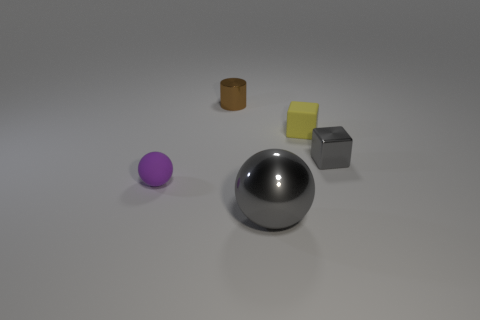Add 5 tiny metallic blocks. How many objects exist? 10 Subtract all balls. How many objects are left? 3 Add 1 small purple rubber balls. How many small purple rubber balls are left? 2 Add 4 tiny brown shiny things. How many tiny brown shiny things exist? 5 Subtract 0 green cubes. How many objects are left? 5 Subtract all large gray spheres. Subtract all small blue matte blocks. How many objects are left? 4 